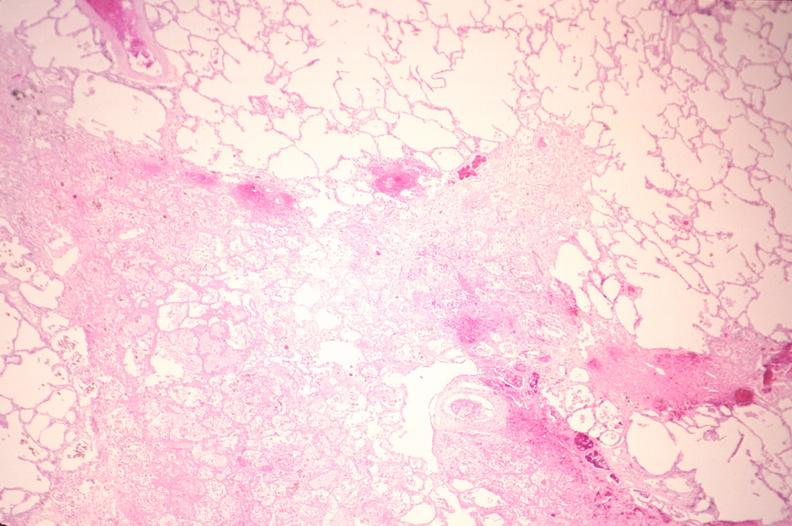s respiratory present?
Answer the question using a single word or phrase. Yes 